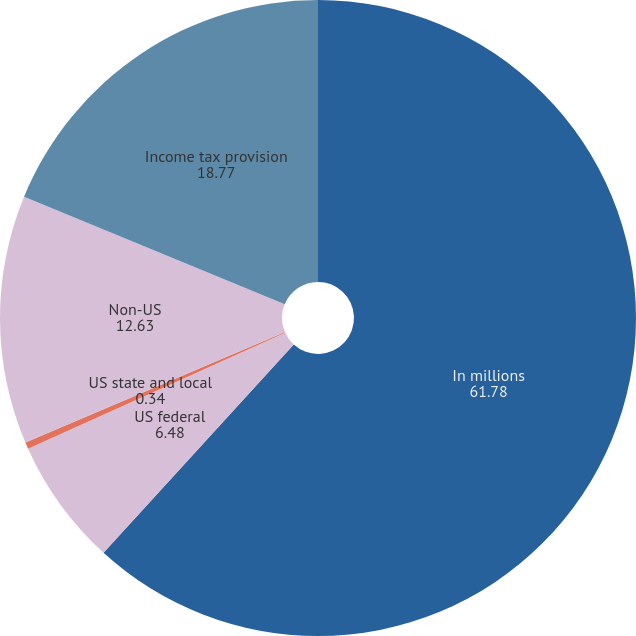Convert chart to OTSL. <chart><loc_0><loc_0><loc_500><loc_500><pie_chart><fcel>In millions<fcel>US federal<fcel>US state and local<fcel>Non-US<fcel>Income tax provision<nl><fcel>61.78%<fcel>6.48%<fcel>0.34%<fcel>12.63%<fcel>18.77%<nl></chart> 